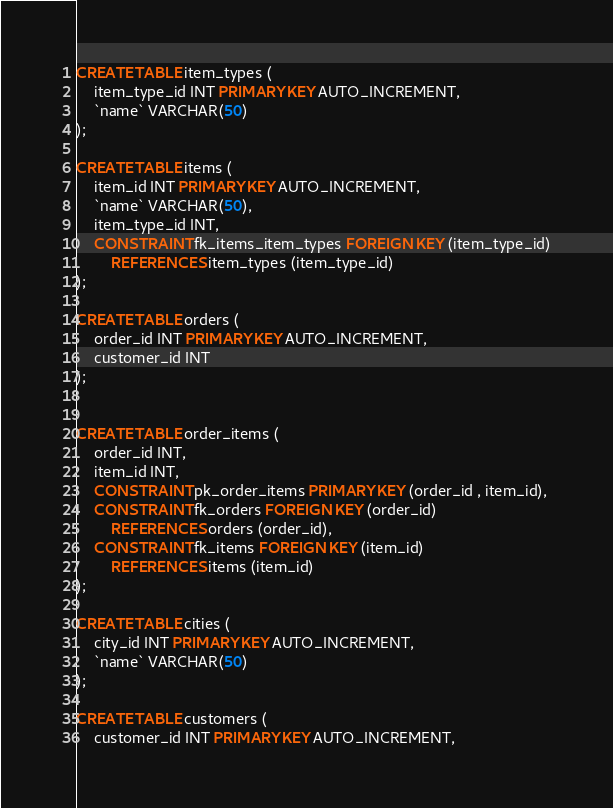<code> <loc_0><loc_0><loc_500><loc_500><_SQL_>CREATE TABLE item_types (
    item_type_id INT PRIMARY KEY AUTO_INCREMENT,
    `name` VARCHAR(50)
);

CREATE TABLE items (
    item_id INT PRIMARY KEY AUTO_INCREMENT,
    `name` VARCHAR(50),
    item_type_id INT,
    CONSTRAINT fk_items_item_types FOREIGN KEY (item_type_id)
        REFERENCES item_types (item_type_id)
);

CREATE TABLE orders (
    order_id INT PRIMARY KEY AUTO_INCREMENT,
    customer_id INT
);


CREATE TABLE order_items (
    order_id INT,
    item_id INT,
    CONSTRAINT pk_order_items PRIMARY KEY (order_id , item_id),
    CONSTRAINT fk_orders FOREIGN KEY (order_id)
        REFERENCES orders (order_id),
    CONSTRAINT fk_items FOREIGN KEY (item_id)
        REFERENCES items (item_id)
);

CREATE TABLE cities (
    city_id INT PRIMARY KEY AUTO_INCREMENT,
    `name` VARCHAR(50)
);

CREATE TABLE customers (
    customer_id INT PRIMARY KEY AUTO_INCREMENT,</code> 